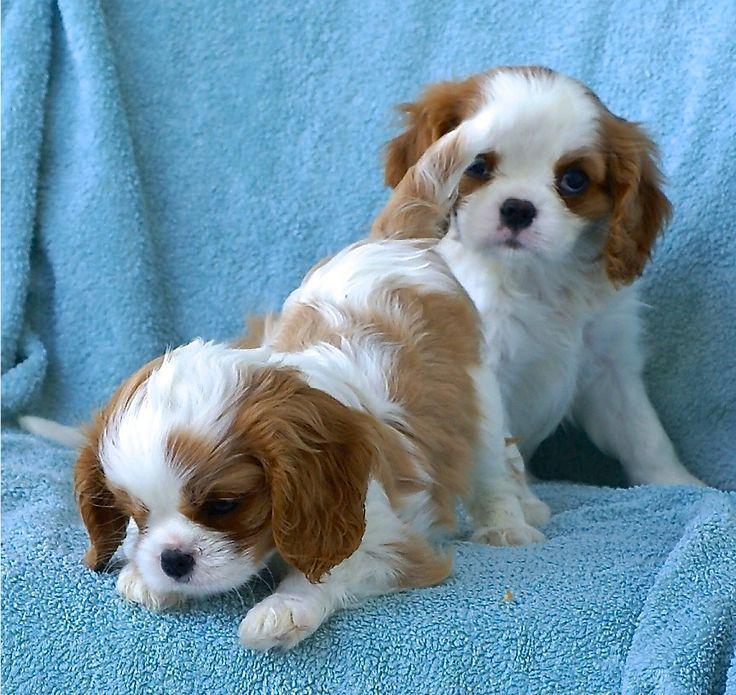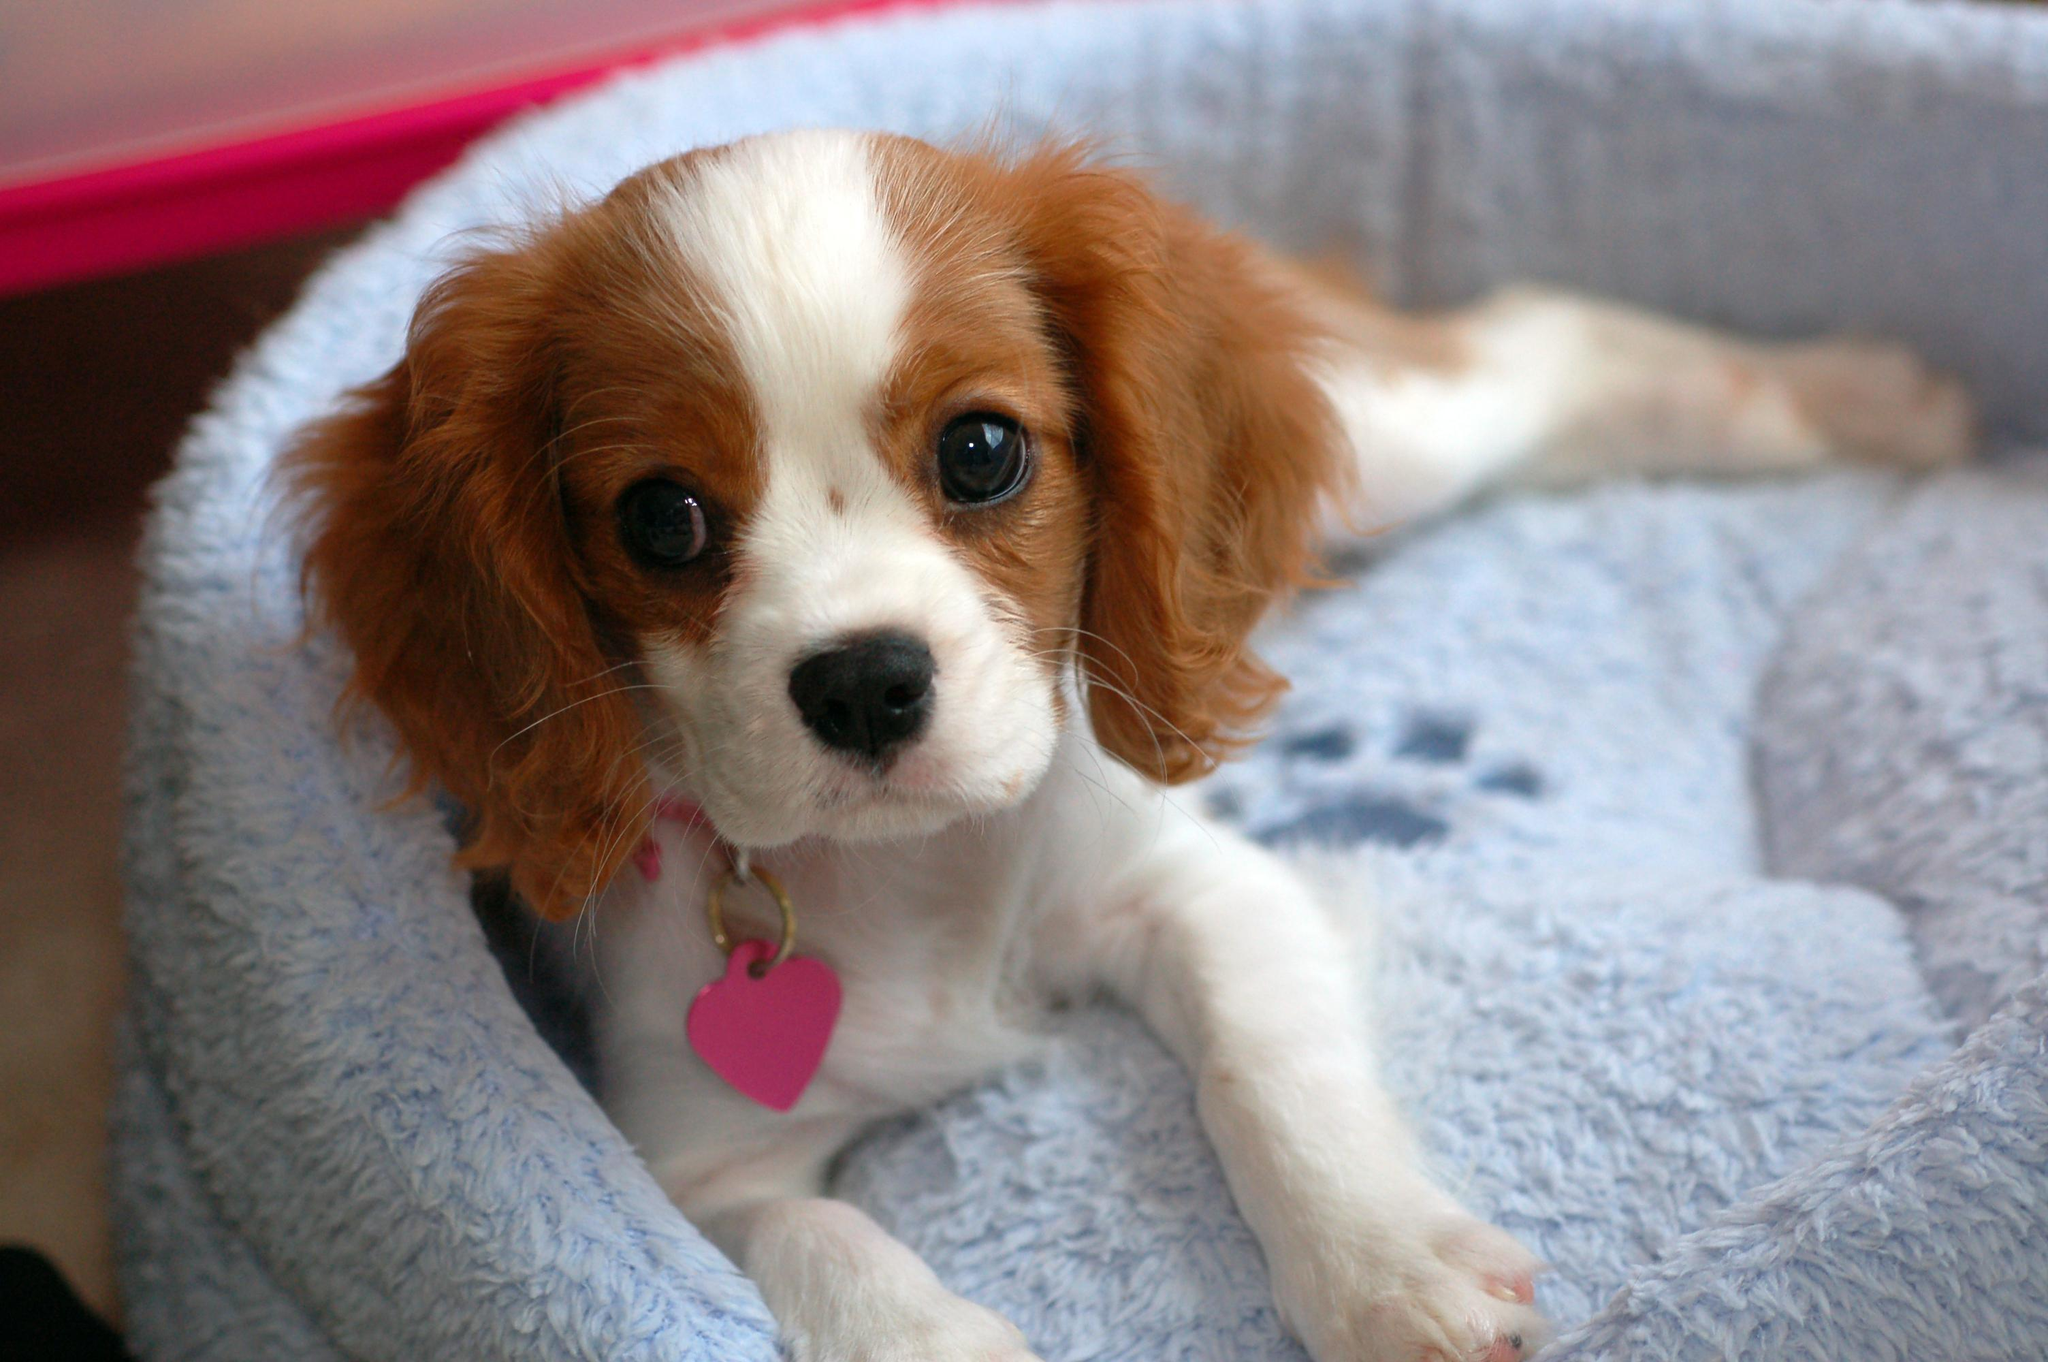The first image is the image on the left, the second image is the image on the right. For the images shown, is this caption "There are three mammals visible" true? Answer yes or no. Yes. The first image is the image on the left, the second image is the image on the right. Evaluate the accuracy of this statement regarding the images: "There is a single dog outside in each image.". Is it true? Answer yes or no. No. 